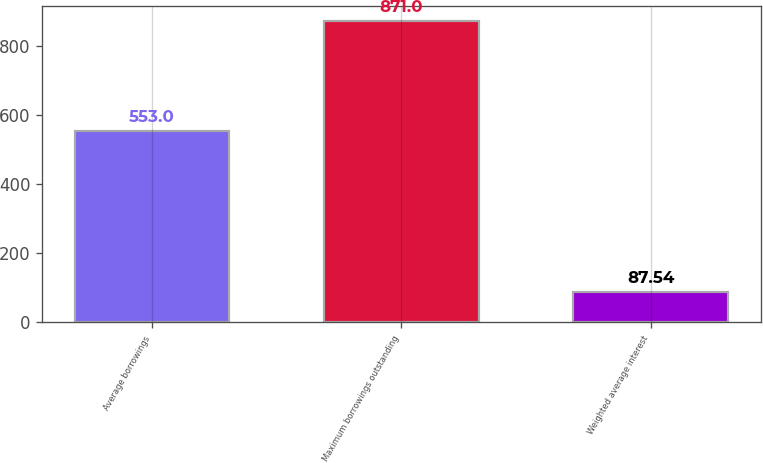<chart> <loc_0><loc_0><loc_500><loc_500><bar_chart><fcel>Average borrowings<fcel>Maximum borrowings outstanding<fcel>Weighted average interest<nl><fcel>553<fcel>871<fcel>87.54<nl></chart> 